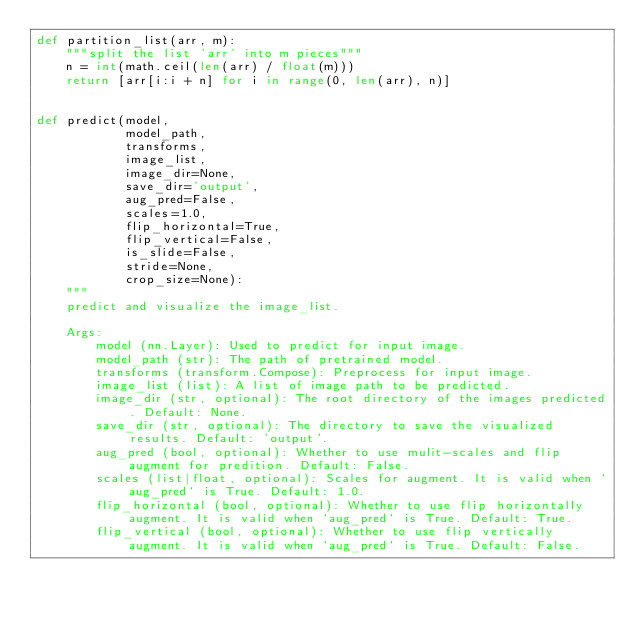Convert code to text. <code><loc_0><loc_0><loc_500><loc_500><_Python_>def partition_list(arr, m):
    """split the list 'arr' into m pieces"""
    n = int(math.ceil(len(arr) / float(m)))
    return [arr[i:i + n] for i in range(0, len(arr), n)]


def predict(model,
            model_path,
            transforms,
            image_list,
            image_dir=None,
            save_dir='output',
            aug_pred=False,
            scales=1.0,
            flip_horizontal=True,
            flip_vertical=False,
            is_slide=False,
            stride=None,
            crop_size=None):
    """
    predict and visualize the image_list.

    Args:
        model (nn.Layer): Used to predict for input image.
        model_path (str): The path of pretrained model.
        transforms (transform.Compose): Preprocess for input image.
        image_list (list): A list of image path to be predicted.
        image_dir (str, optional): The root directory of the images predicted. Default: None.
        save_dir (str, optional): The directory to save the visualized results. Default: 'output'.
        aug_pred (bool, optional): Whether to use mulit-scales and flip augment for predition. Default: False.
        scales (list|float, optional): Scales for augment. It is valid when `aug_pred` is True. Default: 1.0.
        flip_horizontal (bool, optional): Whether to use flip horizontally augment. It is valid when `aug_pred` is True. Default: True.
        flip_vertical (bool, optional): Whether to use flip vertically augment. It is valid when `aug_pred` is True. Default: False.</code> 